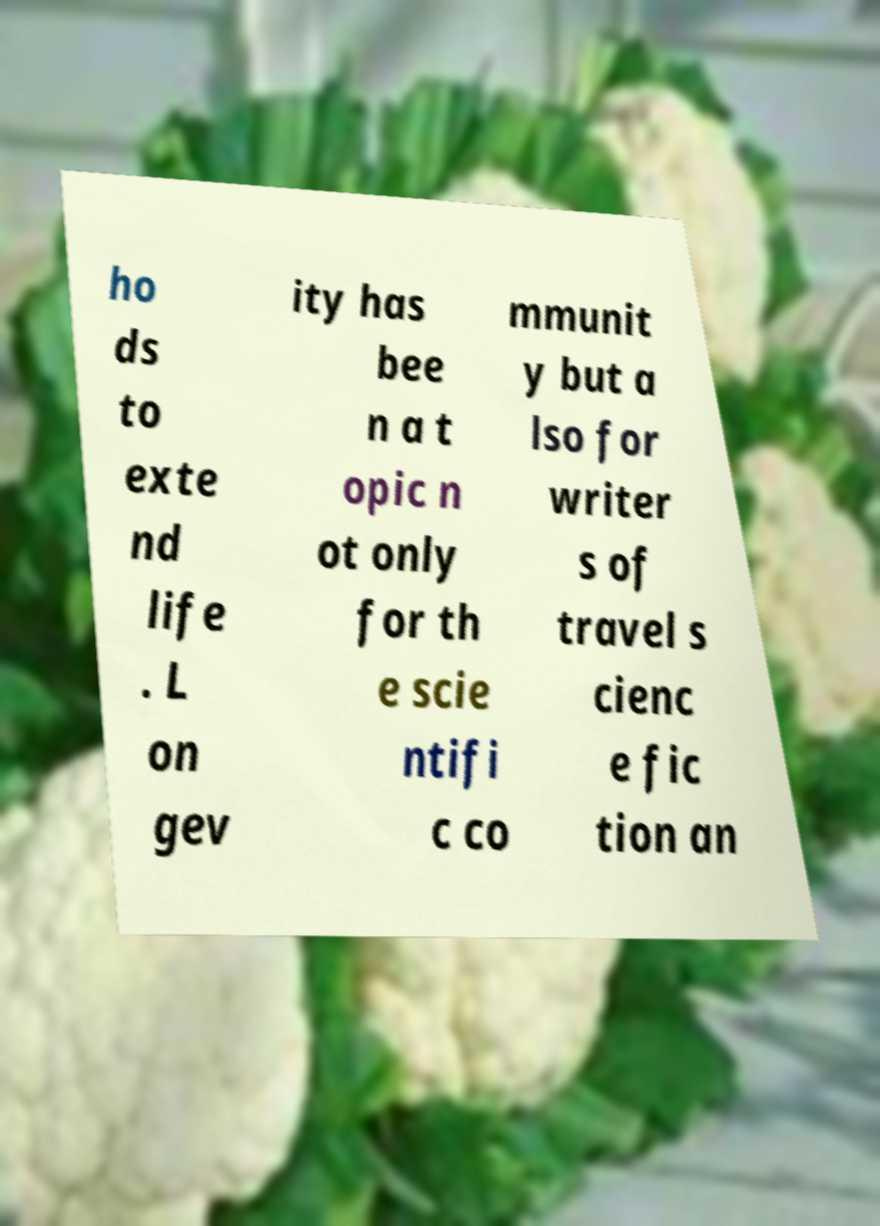Please identify and transcribe the text found in this image. ho ds to exte nd life . L on gev ity has bee n a t opic n ot only for th e scie ntifi c co mmunit y but a lso for writer s of travel s cienc e fic tion an 